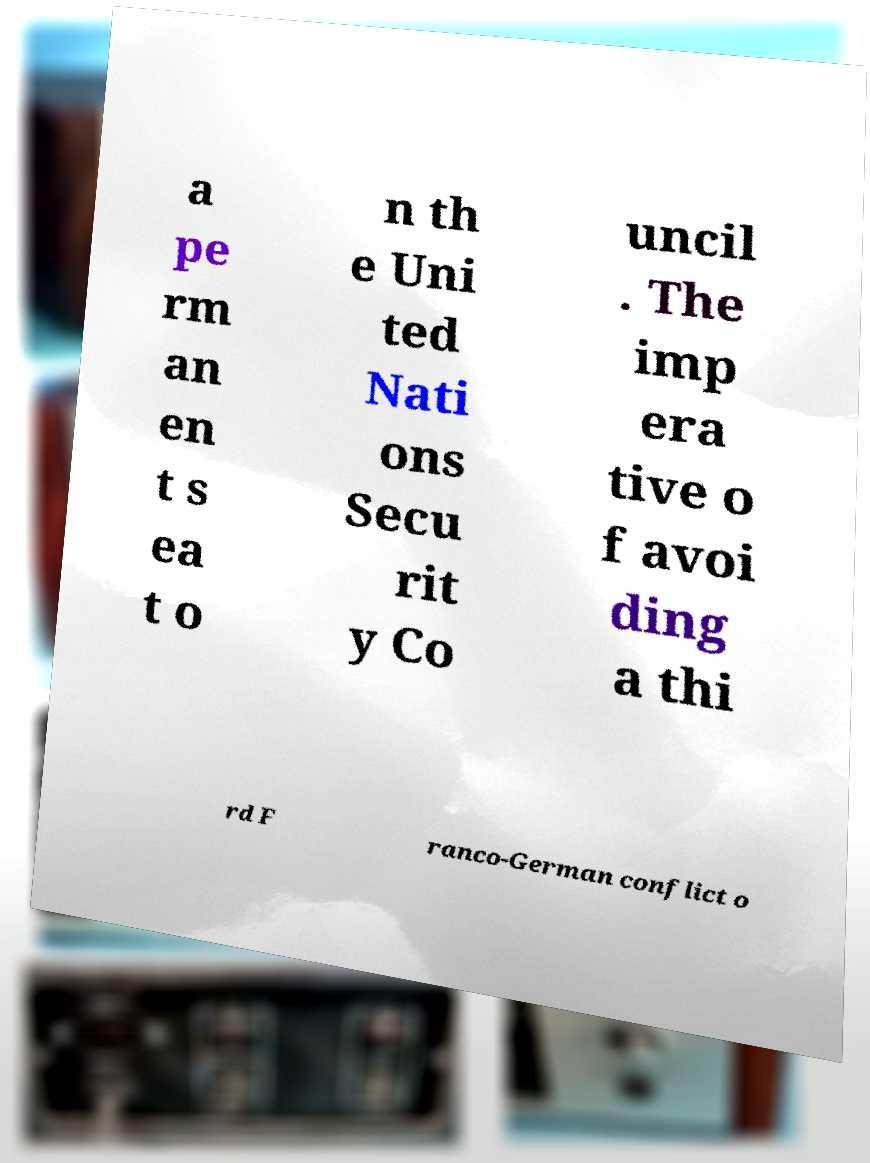Can you accurately transcribe the text from the provided image for me? a pe rm an en t s ea t o n th e Uni ted Nati ons Secu rit y Co uncil . The imp era tive o f avoi ding a thi rd F ranco-German conflict o 